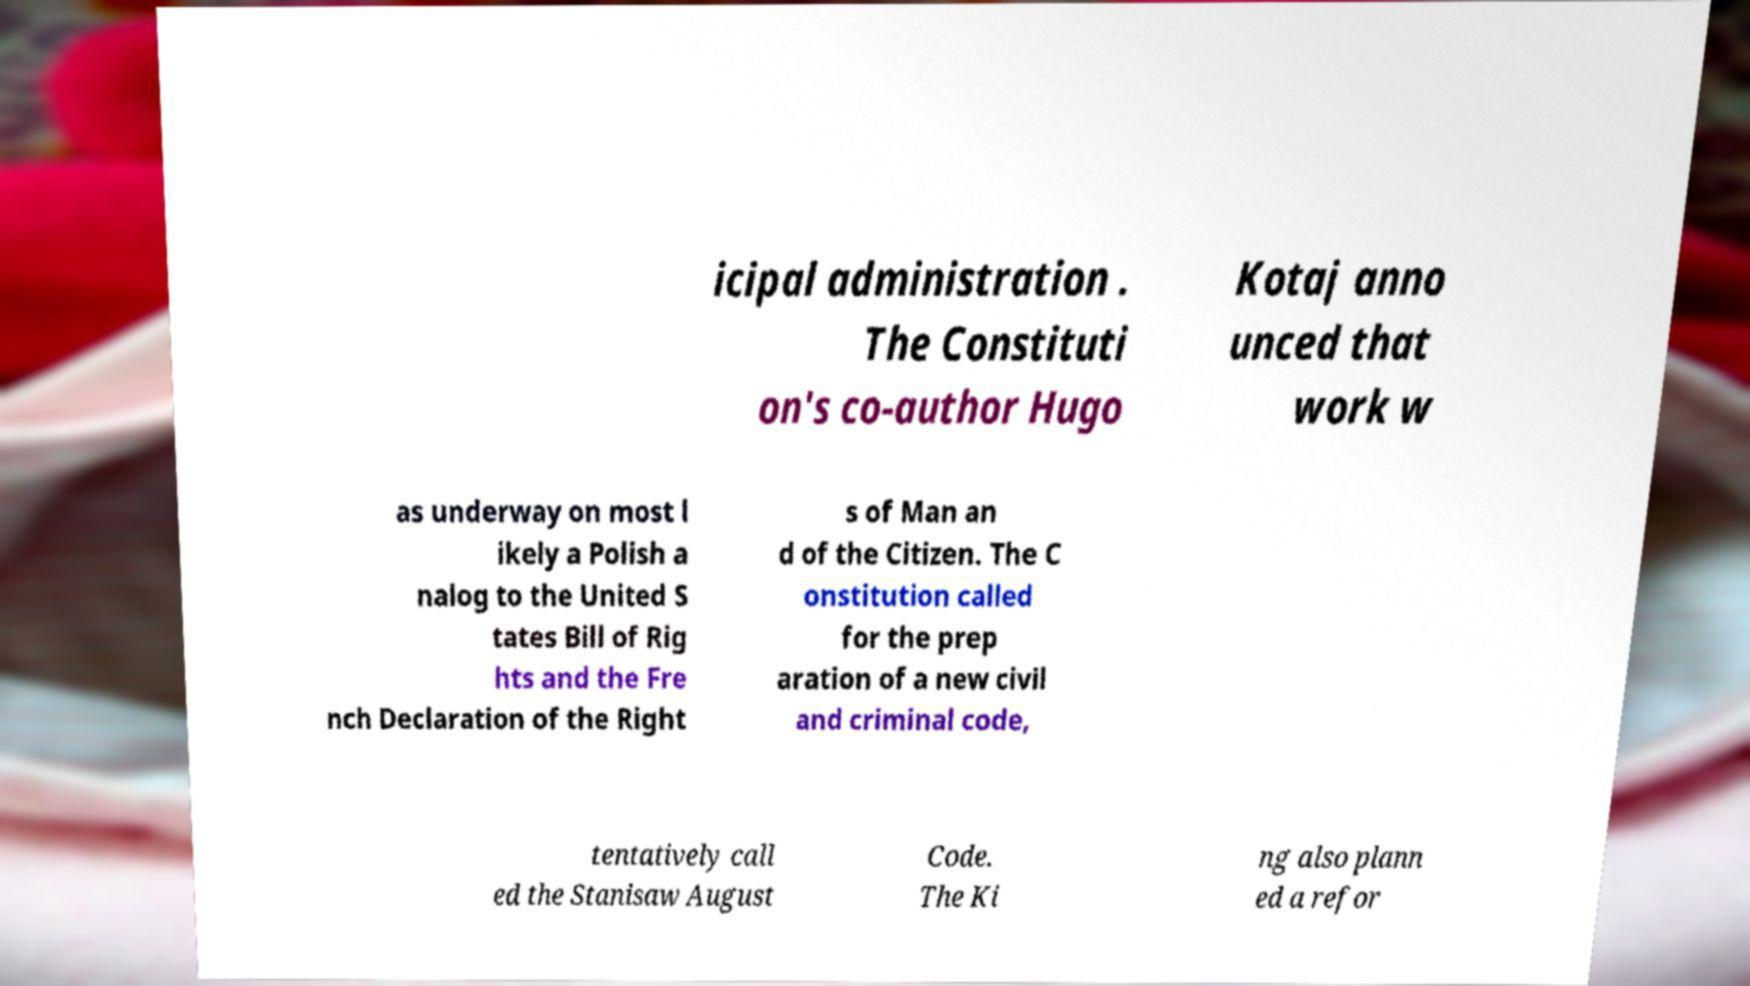Could you assist in decoding the text presented in this image and type it out clearly? icipal administration . The Constituti on's co-author Hugo Kotaj anno unced that work w as underway on most l ikely a Polish a nalog to the United S tates Bill of Rig hts and the Fre nch Declaration of the Right s of Man an d of the Citizen. The C onstitution called for the prep aration of a new civil and criminal code, tentatively call ed the Stanisaw August Code. The Ki ng also plann ed a refor 